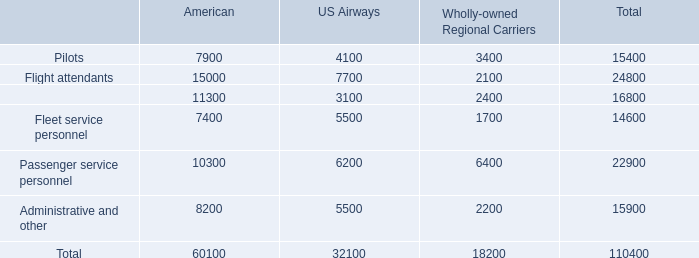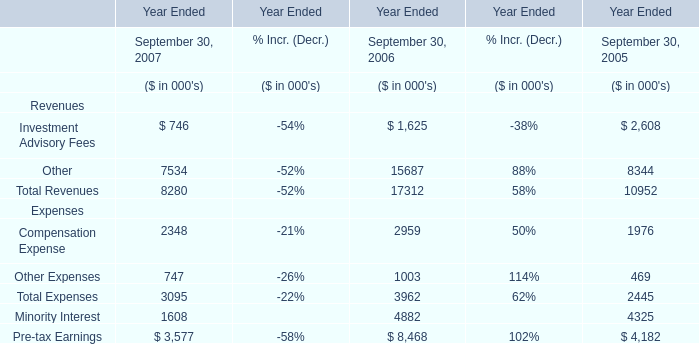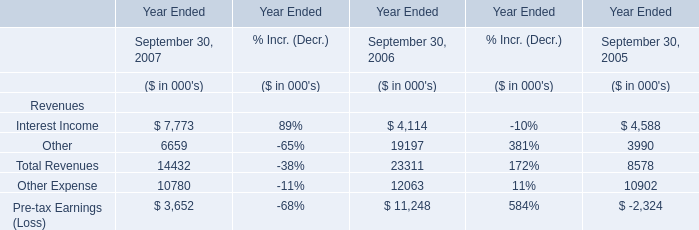What was the total amount of the Earnings in the years where total revenue is greater than 20000? (in thousand) 
Computations: ((4114 + 19197) - 12063)
Answer: 11248.0. 